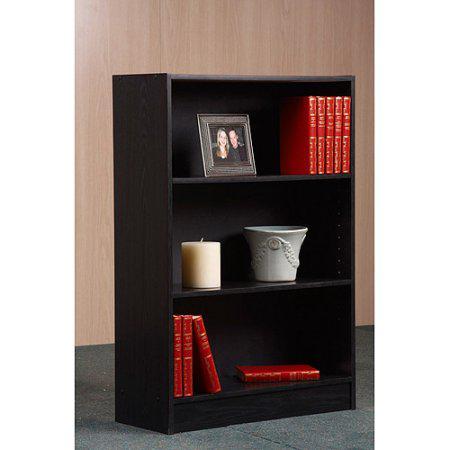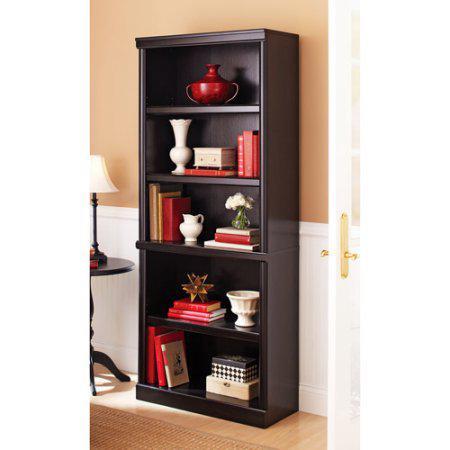The first image is the image on the left, the second image is the image on the right. For the images displayed, is the sentence "There is a white pail shaped vase on a shelf." factually correct? Answer yes or no. Yes. 